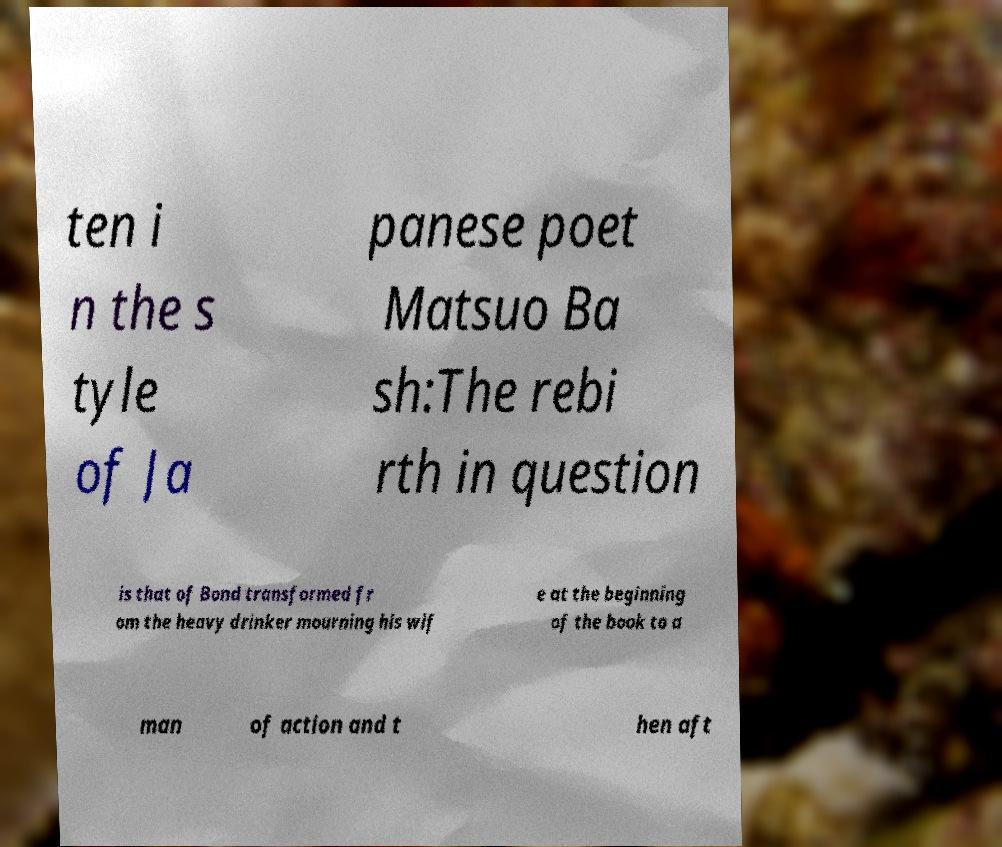There's text embedded in this image that I need extracted. Can you transcribe it verbatim? ten i n the s tyle of Ja panese poet Matsuo Ba sh:The rebi rth in question is that of Bond transformed fr om the heavy drinker mourning his wif e at the beginning of the book to a man of action and t hen aft 